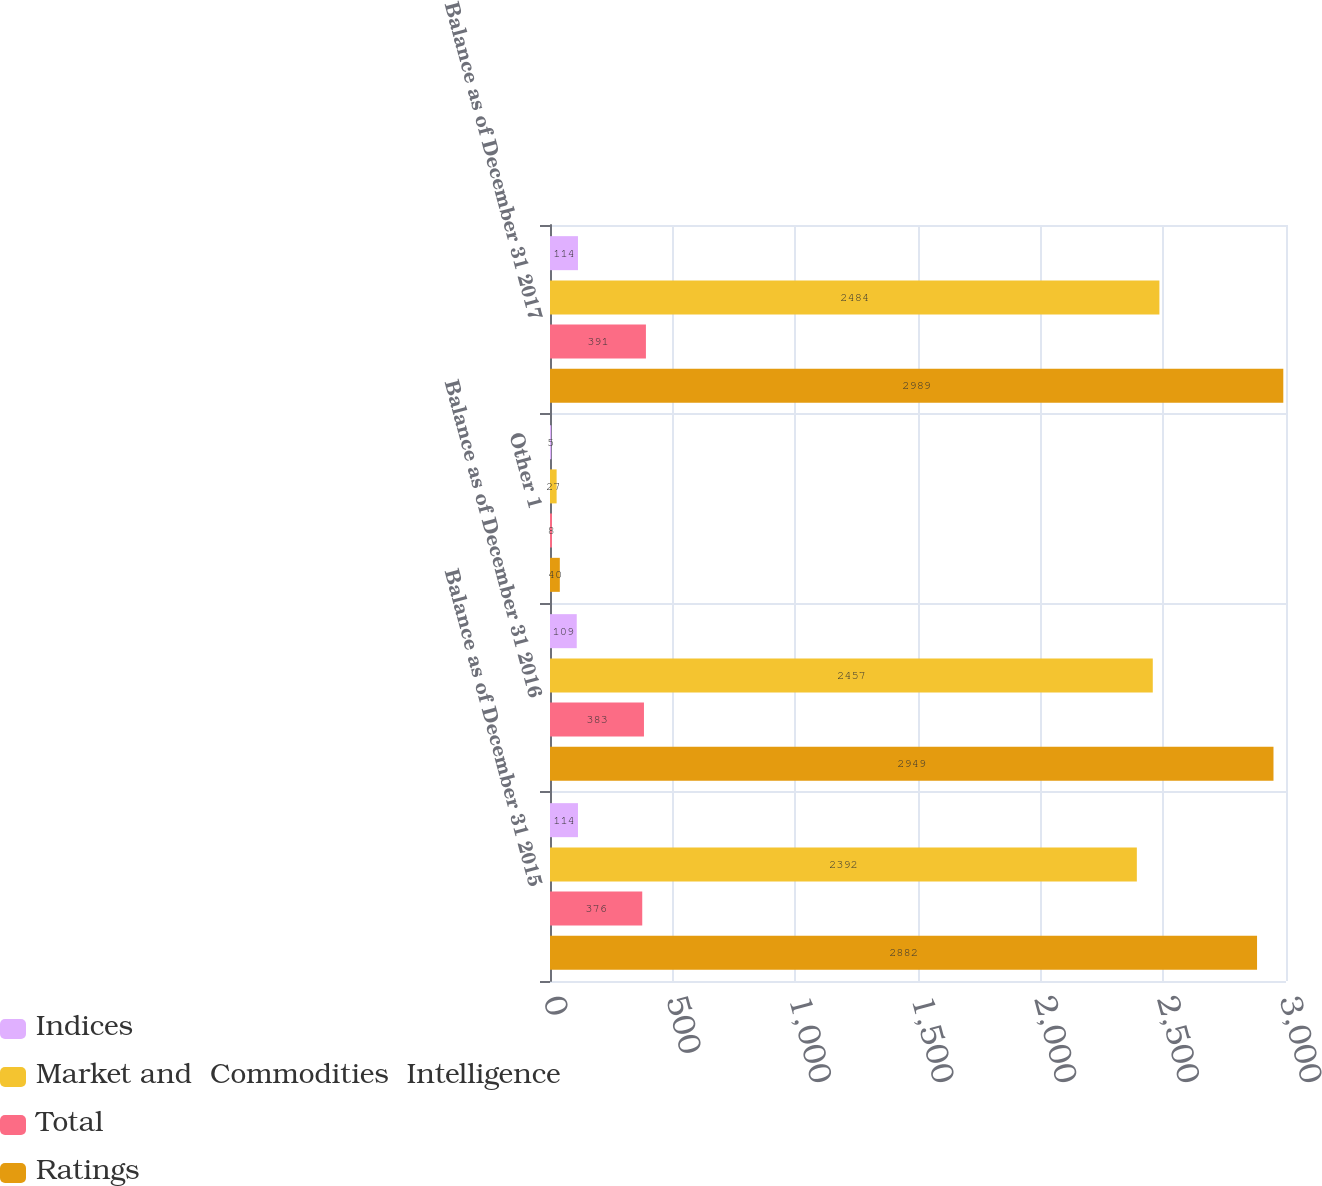Convert chart. <chart><loc_0><loc_0><loc_500><loc_500><stacked_bar_chart><ecel><fcel>Balance as of December 31 2015<fcel>Balance as of December 31 2016<fcel>Other 1<fcel>Balance as of December 31 2017<nl><fcel>Indices<fcel>114<fcel>109<fcel>5<fcel>114<nl><fcel>Market and  Commodities  Intelligence<fcel>2392<fcel>2457<fcel>27<fcel>2484<nl><fcel>Total<fcel>376<fcel>383<fcel>8<fcel>391<nl><fcel>Ratings<fcel>2882<fcel>2949<fcel>40<fcel>2989<nl></chart> 